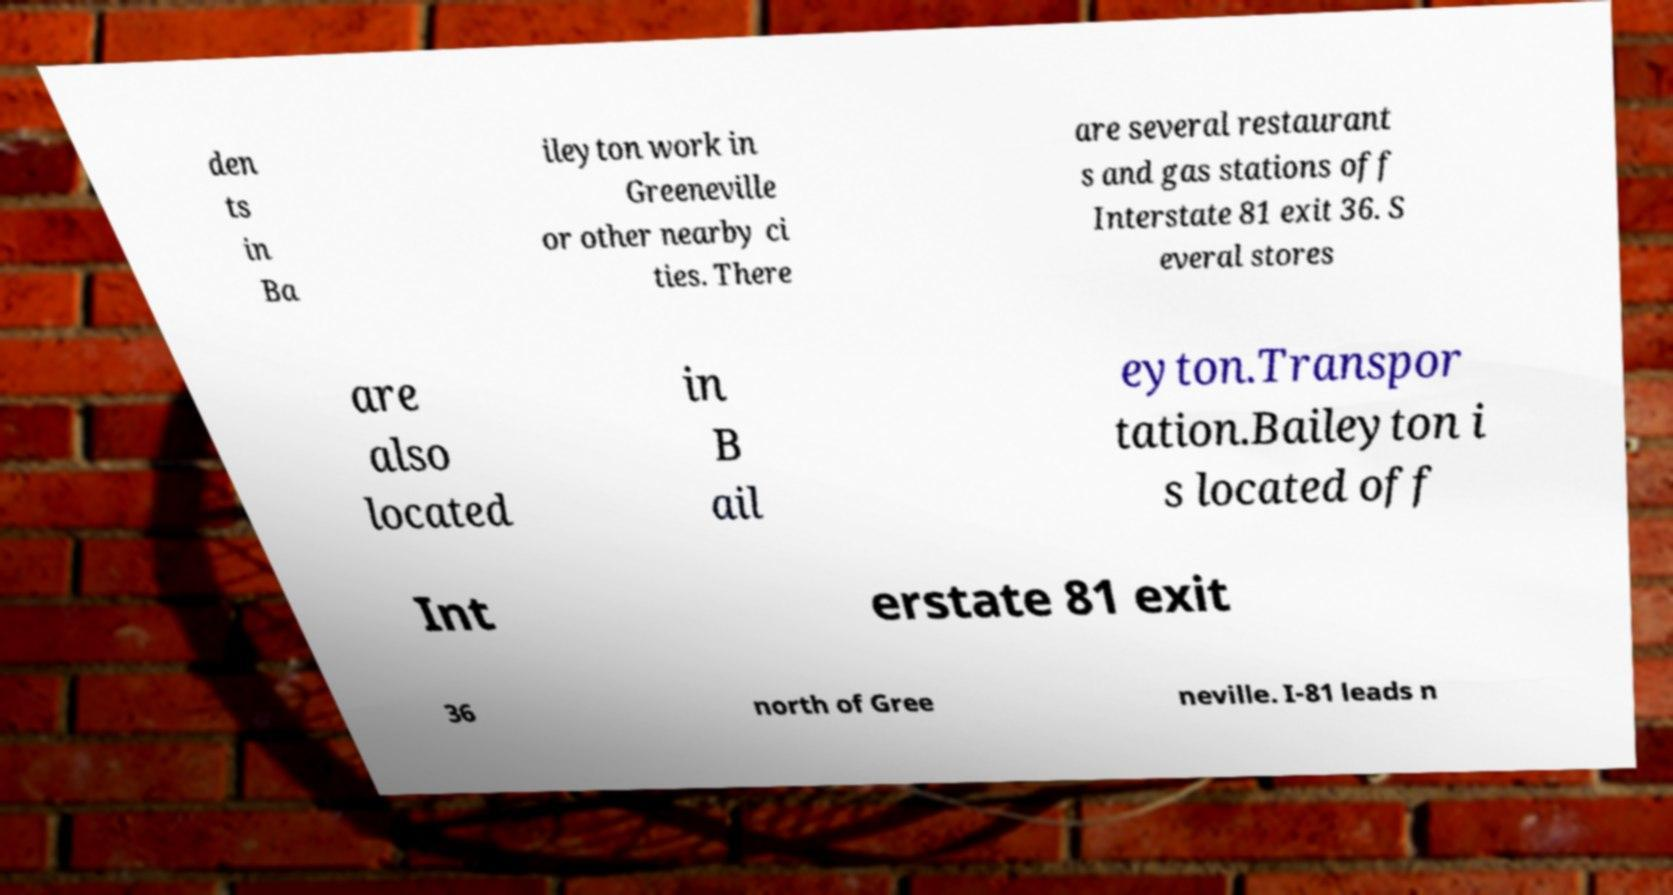Please identify and transcribe the text found in this image. den ts in Ba ileyton work in Greeneville or other nearby ci ties. There are several restaurant s and gas stations off Interstate 81 exit 36. S everal stores are also located in B ail eyton.Transpor tation.Baileyton i s located off Int erstate 81 exit 36 north of Gree neville. I-81 leads n 